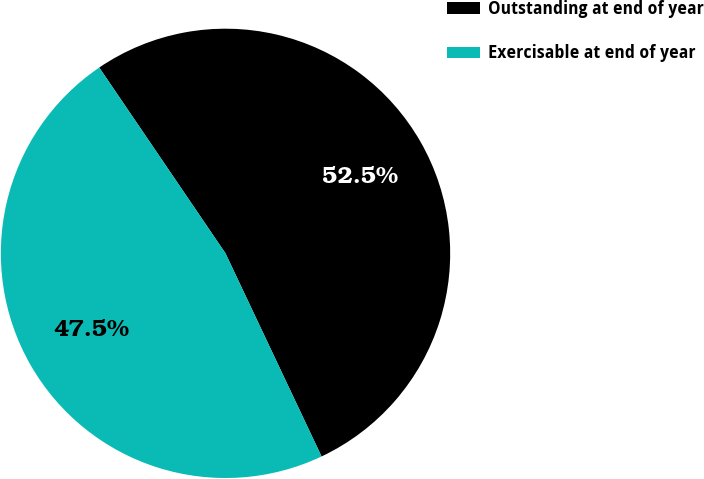<chart> <loc_0><loc_0><loc_500><loc_500><pie_chart><fcel>Outstanding at end of year<fcel>Exercisable at end of year<nl><fcel>52.47%<fcel>47.53%<nl></chart> 